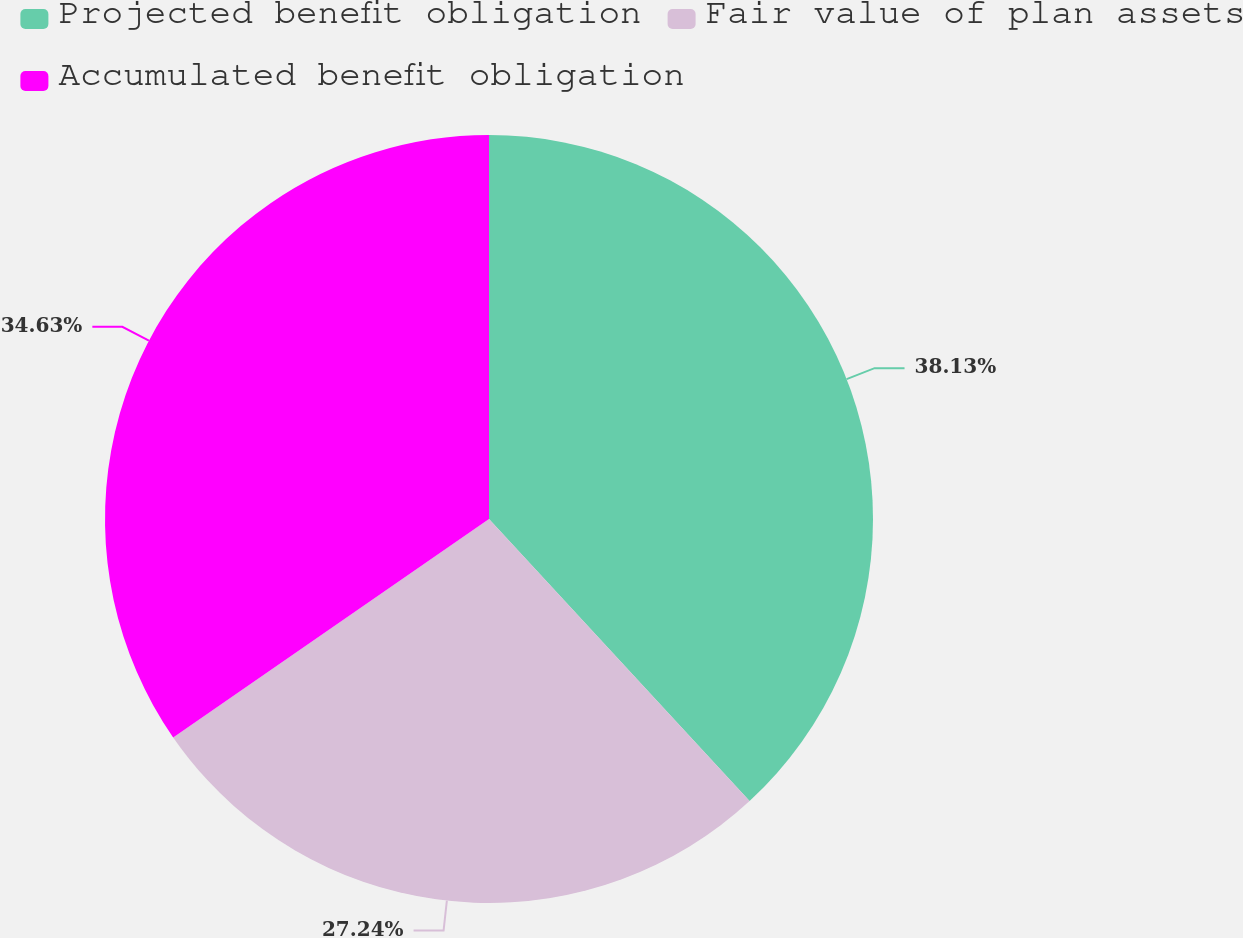<chart> <loc_0><loc_0><loc_500><loc_500><pie_chart><fcel>Projected benefit obligation<fcel>Fair value of plan assets<fcel>Accumulated benefit obligation<nl><fcel>38.13%<fcel>27.24%<fcel>34.63%<nl></chart> 